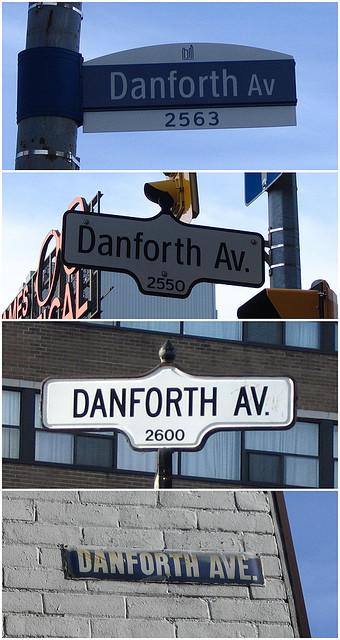Are the signs in the same area?
Give a very brief answer. Yes. What Avenue is seen?
Short answer required. Danforth. Do all the signs have a number on them?
Short answer required. No. 